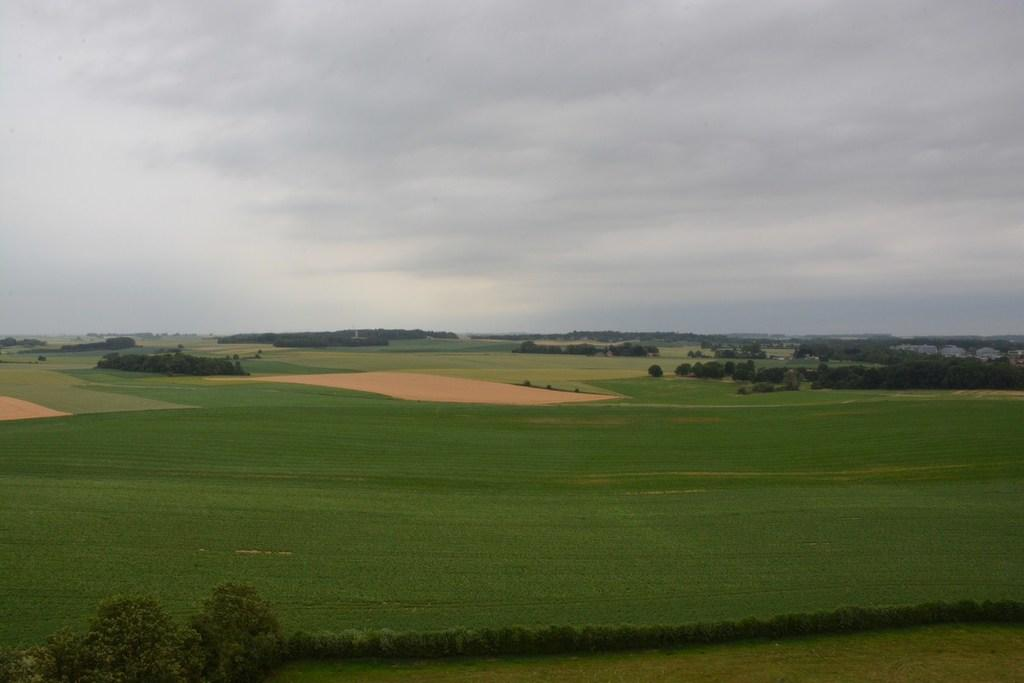What type of vegetation can be seen in the image? There are plants and trees visible in the image. What type of ground cover is present in the image? There is grass visible in the image. What can be seen in the sky in the image? There are clouds in the sky in the image. Where is the throne located in the image? There is no throne present in the image. What type of scarf is draped over the stage in the image? There is no stage or scarf present in the image. 